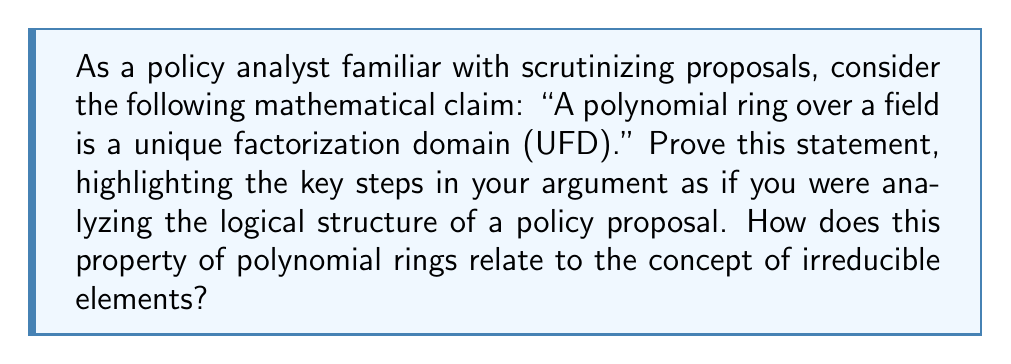Can you solve this math problem? To prove that a polynomial ring over a field is a unique factorization domain (UFD), we'll follow a step-by-step approach, similar to analyzing a policy proposal:

1. Define the key terms:
   - Let $F$ be a field.
   - Let $F[x]$ be the ring of polynomials over $F$ in one variable $x$.

2. Establish the foundation:
   - Recall that a UFD is an integral domain in which every non-zero non-unit element can be factored uniquely (up to associates) as a product of irreducible elements.

3. Prove that $F[x]$ is an integral domain:
   - $F[x]$ is commutative with unity (inherited from $F$).
   - For non-zero polynomials $f(x)$ and $g(x)$ in $F[x]$, their product $f(x)g(x)$ has degree equal to the sum of their degrees, hence non-zero.
   - Therefore, $F[x]$ has no zero divisors and is an integral domain.

4. Identify the units in $F[x]$:
   - The units in $F[x]$ are precisely the non-zero constant polynomials (elements of $F$).

5. Define and characterize irreducible polynomials:
   - A non-constant polynomial $p(x) \in F[x]$ is irreducible if it cannot be factored as a product of two non-constant polynomials in $F[x]$.

6. Prove the existence of irreducible factorizations:
   - Use the degree of polynomials: For any non-zero non-constant polynomial $f(x) \in F[x]$, if it's not irreducible, it can be factored into polynomials of smaller degree.
   - This process must terminate due to the well-ordering principle on the natural numbers (degrees), resulting in a factorization into irreducibles.

7. Prove the uniqueness of irreducible factorizations:
   - Use Gauss's Lemma: If a primitive polynomial in $F[x]$ factors over the field of fractions of $F$, then it factors over $F$ itself.
   - Apply induction on the degree of the polynomial.
   - For the base case, consider linear polynomials, which are irreducible.
   - For the inductive step, assume uniqueness for polynomials of degree less than $n$, and prove for degree $n$.

8. Conclude:
   - We have shown that every non-zero non-unit element in $F[x]$ can be factored uniquely (up to associates) as a product of irreducible elements.
   - Therefore, $F[x]$ satisfies the definition of a UFD.

This proof structure resembles policy analysis in that it breaks down a complex claim into manageable components, establishes foundational principles, and builds a logical argument step by step.
Answer: A polynomial ring $F[x]$ over a field $F$ is a unique factorization domain because:
1. It is an integral domain.
2. Every non-zero non-unit element can be factored into irreducible polynomials.
3. This factorization is unique up to associates (unit multiples).
The key steps involve proving the existence of irreducible factorizations using the degree of polynomials and proving uniqueness using Gauss's Lemma and induction on the degree. 